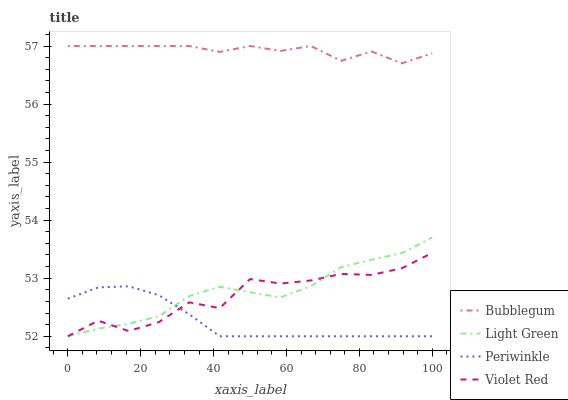Does Periwinkle have the minimum area under the curve?
Answer yes or no. Yes. Does Bubblegum have the maximum area under the curve?
Answer yes or no. Yes. Does Light Green have the minimum area under the curve?
Answer yes or no. No. Does Light Green have the maximum area under the curve?
Answer yes or no. No. Is Periwinkle the smoothest?
Answer yes or no. Yes. Is Violet Red the roughest?
Answer yes or no. Yes. Is Light Green the smoothest?
Answer yes or no. No. Is Light Green the roughest?
Answer yes or no. No. Does Bubblegum have the lowest value?
Answer yes or no. No. Does Light Green have the highest value?
Answer yes or no. No. Is Light Green less than Bubblegum?
Answer yes or no. Yes. Is Bubblegum greater than Periwinkle?
Answer yes or no. Yes. Does Light Green intersect Bubblegum?
Answer yes or no. No. 